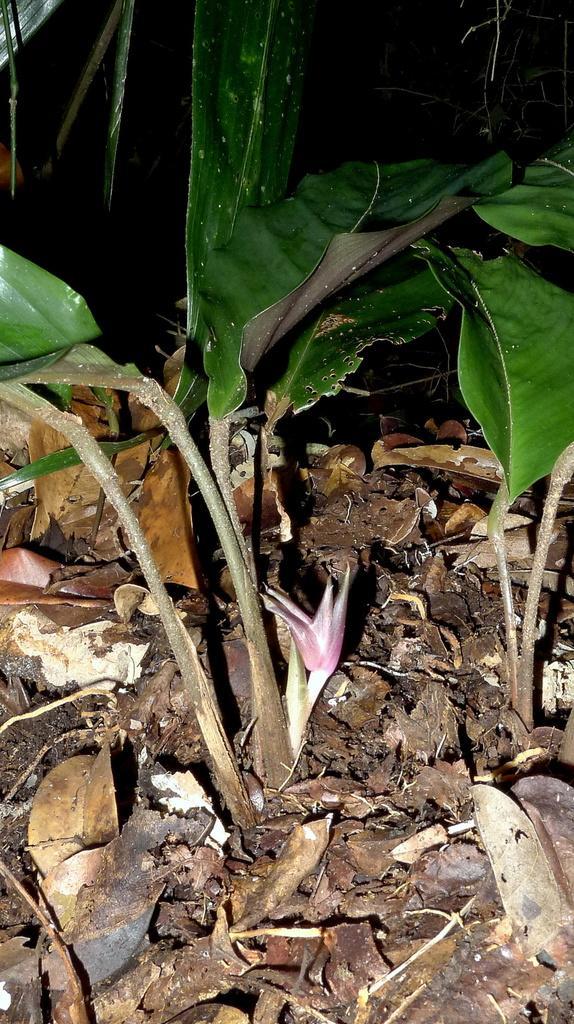Please provide a concise description of this image. In this image in the front there is plant and on the ground there are dry leaves. 